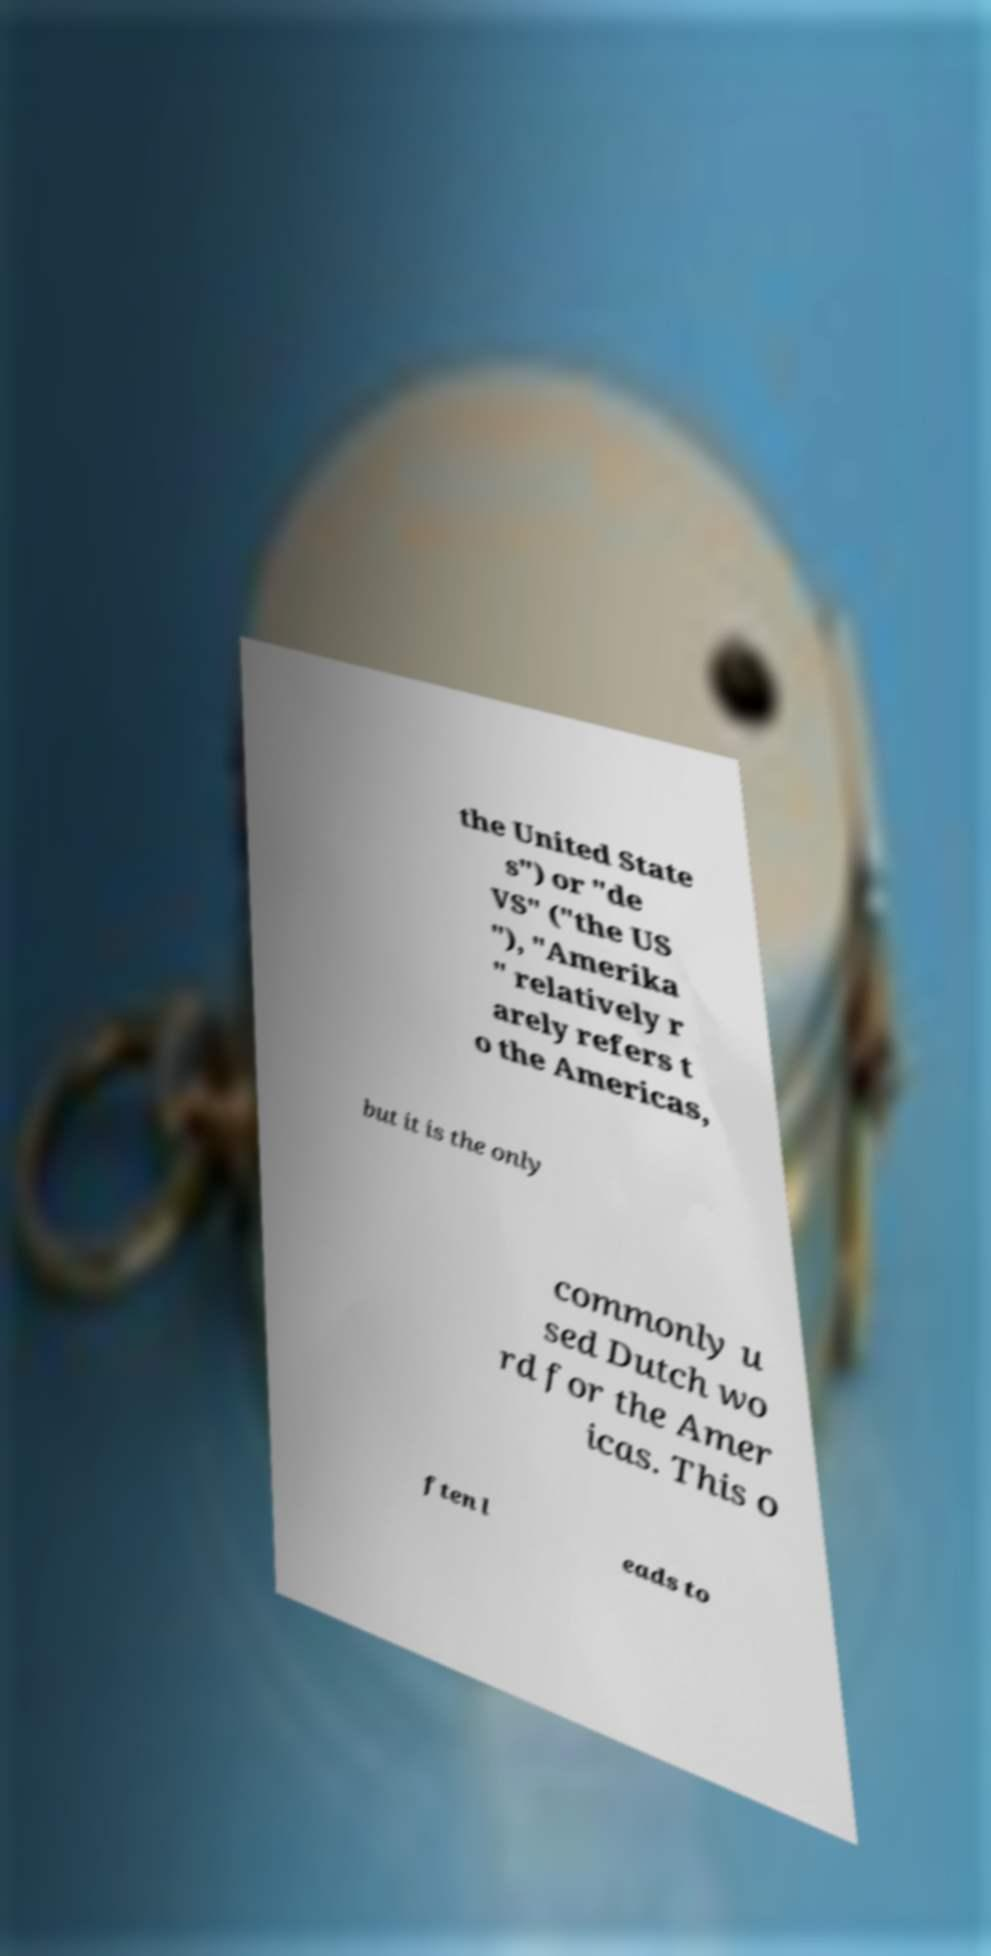Please read and relay the text visible in this image. What does it say? the United State s") or "de VS" ("the US "), "Amerika " relatively r arely refers t o the Americas, but it is the only commonly u sed Dutch wo rd for the Amer icas. This o ften l eads to 